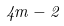Convert formula to latex. <formula><loc_0><loc_0><loc_500><loc_500>4 m - 2</formula> 